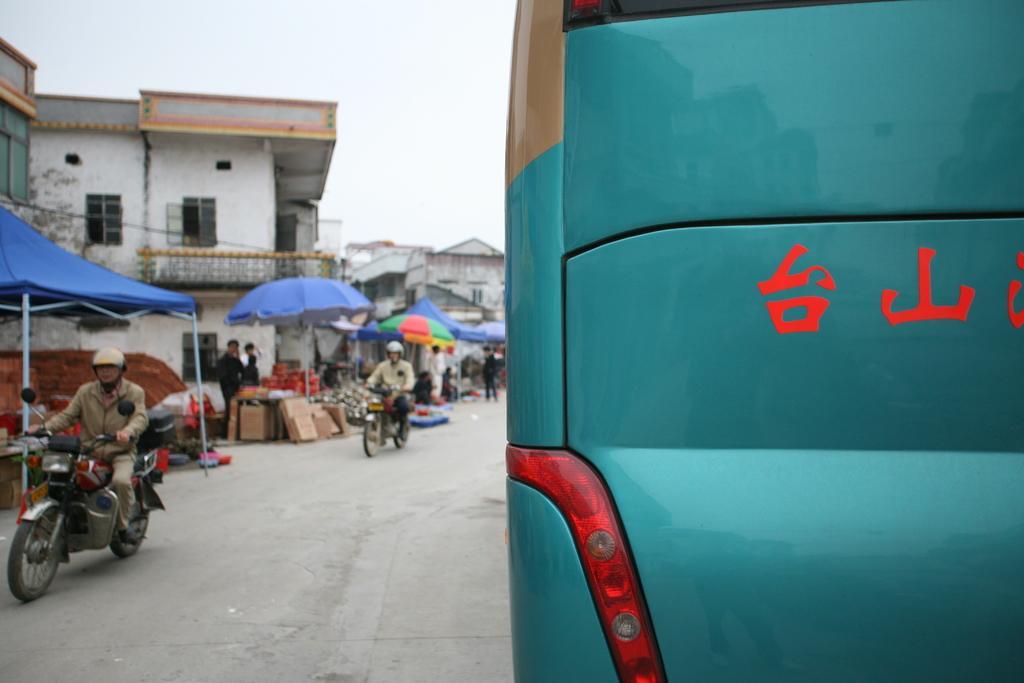Please provide a concise description of this image. In this image I can see few people are on their bikes. I can also see a vehicle, few shades and few buildings. 